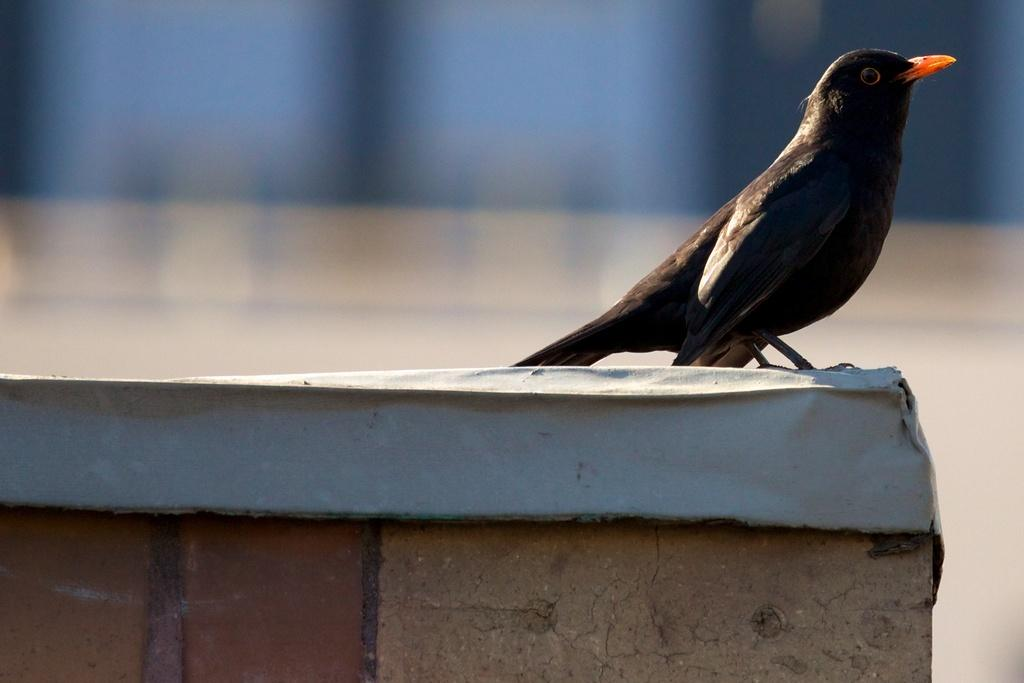What is on the wall in the image? There is a bird on the wall in the image. Can you describe the background of the image? The background of the image is blurred. Where is the chair located in the image? There is no chair present in the image. What type of soda is being served in the image? There is no soda present in the image. 